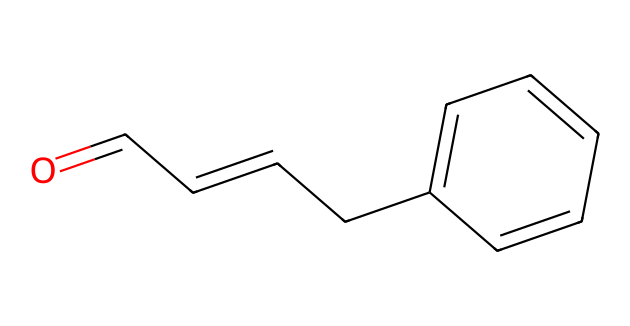What is the molecular formula of cinnamaldehyde? To find the molecular formula, we count the number of carbon (C), hydrogen (H), and oxygen (O) atoms in the structure represented by the SMILES notation. Cinnamaldehyde has 9 carbon atoms, 10 hydrogen atoms, and 1 oxygen atom, which gives the formula C9H8O.
Answer: C9H8O How many rings are present in the structure of cinnamaldehyde? In the SMILES representation, if we look closely, we see that there is a six-membered aromatic ring (the benzene part) but no additional rings. Therefore, there is only one ring present.
Answer: 1 What functional group is present in cinnamaldehyde? The aldehyde functional group is identified by the carbon atom that is double-bonded to the oxygen atom (C=O) at the terminal position of the carbon chain. This characteristic carbon-oxygen bond signifies the presence of the aldehyde functional group.
Answer: aldehyde How many double bonds are in the structure? Analyzing the SMILES, we identify two double bonds: one between the first carbon and the oxygen (C=O) and another found within the carbon chain (C=C). Thus, there are a total of two double bonds in the structure.
Answer: 2 Is cinnamaldehyde a saturated or unsaturated compound? Cinnamaldehyde is classified as unsaturated due to the presence of double bonds in its structure. The presence of such bonds indicates that it does not contain the maximum number of hydrogen atoms that would be present in a saturated compound.
Answer: unsaturated 